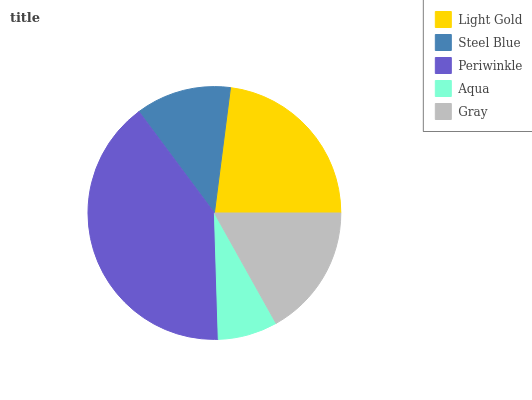Is Aqua the minimum?
Answer yes or no. Yes. Is Periwinkle the maximum?
Answer yes or no. Yes. Is Steel Blue the minimum?
Answer yes or no. No. Is Steel Blue the maximum?
Answer yes or no. No. Is Light Gold greater than Steel Blue?
Answer yes or no. Yes. Is Steel Blue less than Light Gold?
Answer yes or no. Yes. Is Steel Blue greater than Light Gold?
Answer yes or no. No. Is Light Gold less than Steel Blue?
Answer yes or no. No. Is Gray the high median?
Answer yes or no. Yes. Is Gray the low median?
Answer yes or no. Yes. Is Light Gold the high median?
Answer yes or no. No. Is Periwinkle the low median?
Answer yes or no. No. 